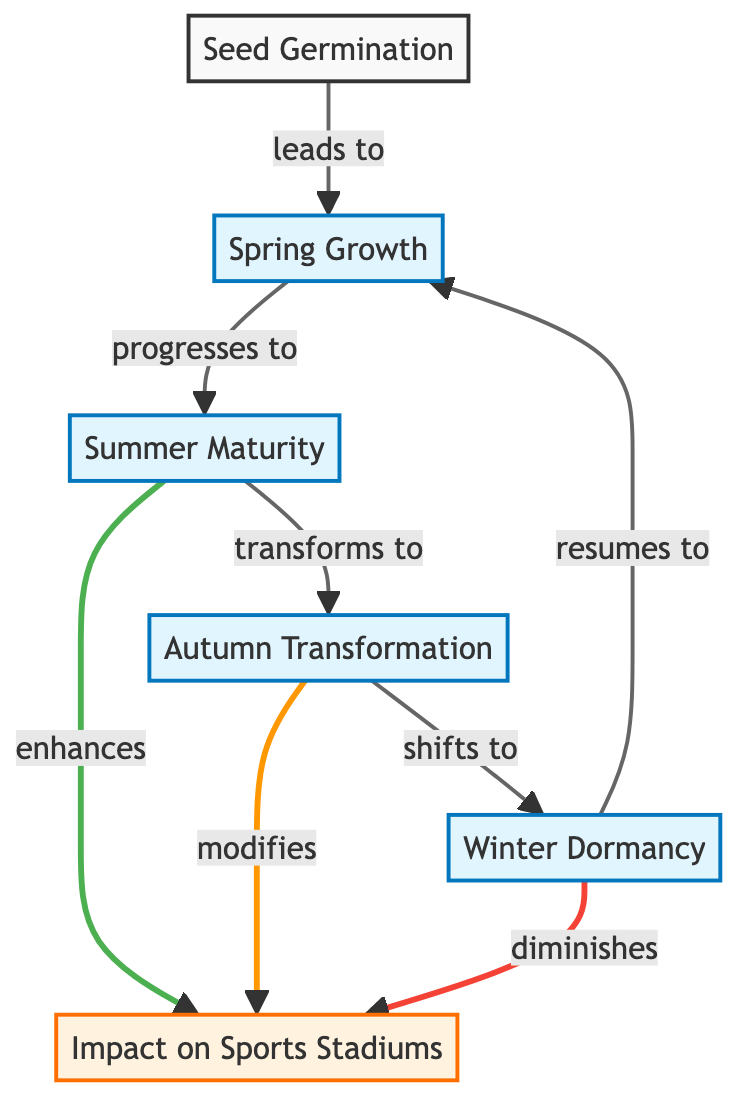What is the first stage in the tree life cycle? The diagram indicates that the first stage is "Seed Germination." This is the initial node and represents the starting point of the life cycle.
Answer: Seed Germination How many seasonal stages are there in the life cycle? The diagram includes three seasonal stages: "Spring Growth," "Summer Maturity," "Autumn Transformation," and "Winter Dormancy." Counting these four stages yields a total of four seasonal stages.
Answer: 4 What does Summer Maturity enhance in sports stadiums? The diagram shows that "Summer Maturity" has a direct relationship with "Impact on Sports Stadiums," specifically enhancing it. This means it positively contributes to the visual aspects during summer in stadiums.
Answer: enhances Which seasonal stage modifies the impact on sports stadiums? According to the diagram, "Autumn Transformation" modifies the impact, indicating that this stage changes how the visual impact is perceived in sports stadiums.
Answer: modifies What leads to Winter Dormancy? The diagram indicates that "Autumn Transformation" shifts to "Winter Dormancy." This shows the direct relationship where Autumn can lead into the dormancy phase.
Answer: Autumn Transformation Which stage resumes the cycle after Winter Dormancy? The diagram states that "Winter Dormancy" resumes to "Spring Growth." This indicates that after the dormancy phase, the cycle returns to the spring stage.
Answer: Spring Growth How does Winter Dormancy affect the impact on sports stadiums? The diagram highlights that "Winter Dormancy" diminishes the impact on sports stadiums, suggesting a reduction in visual appeal during winter months.
Answer: diminishes What seasonal stage comes after Spring Growth? Based on the flow of the diagram, "Spring Growth" progresses to "Summer Maturity." This is a direct line in the lifecycle.
Answer: Summer Maturity Which seasonal stage is the last in the cycle? The final stage in this life cycle is "Winter Dormancy," indicating it is the last phase before the cycle restarts.
Answer: Winter Dormancy 